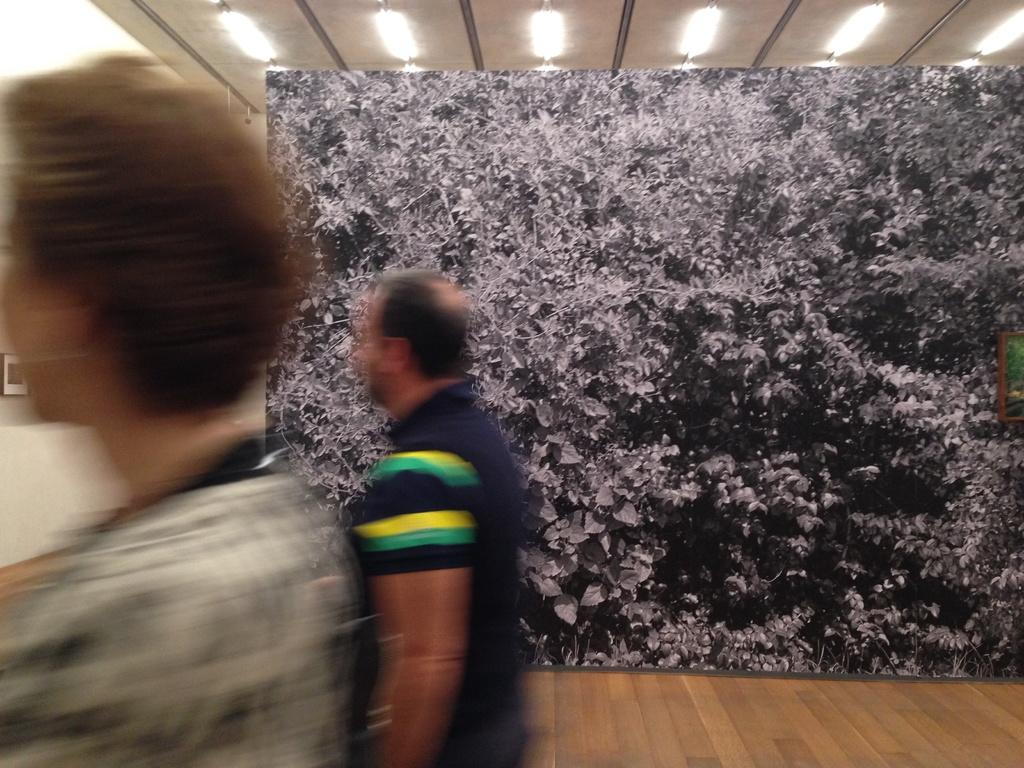How many people can be seen in the image? There are two blurred persons in the image. What is in the background of the image? There is a picture in the background of the image. What is depicted in the picture? The picture contains a number of leaves. What can be seen at the top of the image? There are lights visible at the top of the picture. What type of guide is helping the person in the image? There is no guide present in the image, as it only features two blurred persons and a picture with leaves. 